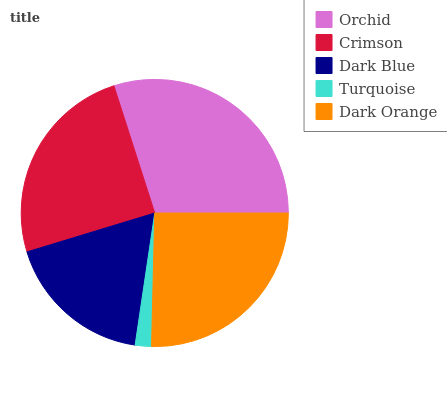Is Turquoise the minimum?
Answer yes or no. Yes. Is Orchid the maximum?
Answer yes or no. Yes. Is Crimson the minimum?
Answer yes or no. No. Is Crimson the maximum?
Answer yes or no. No. Is Orchid greater than Crimson?
Answer yes or no. Yes. Is Crimson less than Orchid?
Answer yes or no. Yes. Is Crimson greater than Orchid?
Answer yes or no. No. Is Orchid less than Crimson?
Answer yes or no. No. Is Crimson the high median?
Answer yes or no. Yes. Is Crimson the low median?
Answer yes or no. Yes. Is Dark Orange the high median?
Answer yes or no. No. Is Dark Orange the low median?
Answer yes or no. No. 